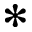<formula> <loc_0><loc_0><loc_500><loc_500>\ast</formula> 